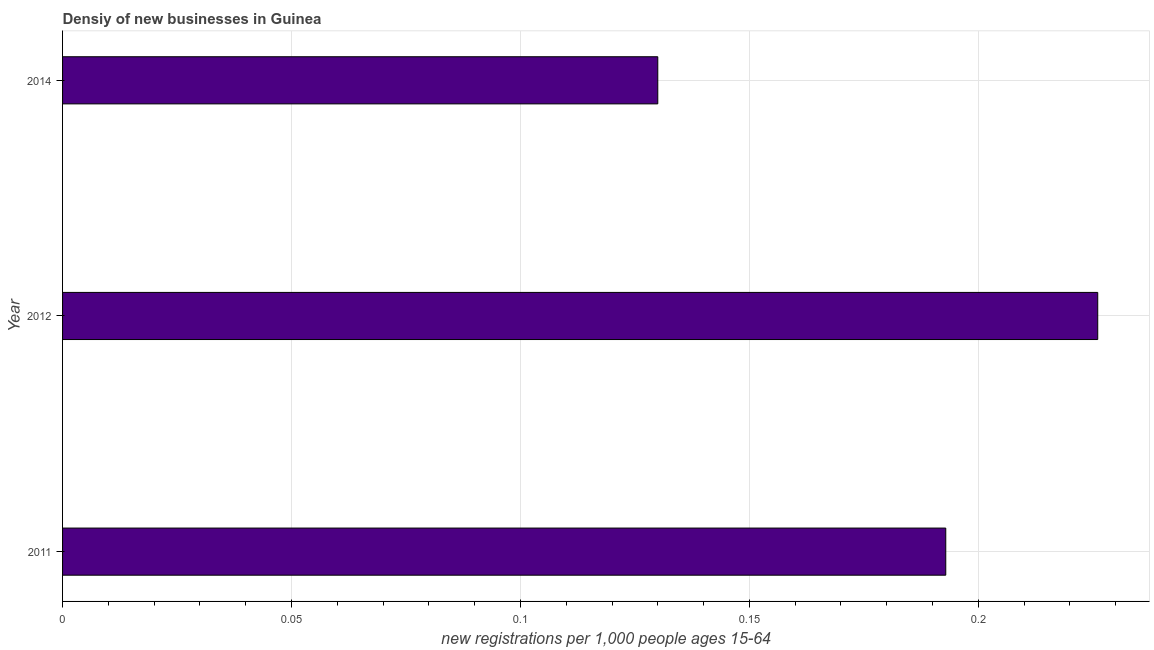Does the graph contain any zero values?
Ensure brevity in your answer.  No. Does the graph contain grids?
Your response must be concise. Yes. What is the title of the graph?
Offer a terse response. Densiy of new businesses in Guinea. What is the label or title of the X-axis?
Your answer should be compact. New registrations per 1,0 people ages 15-64. What is the label or title of the Y-axis?
Offer a very short reply. Year. What is the density of new business in 2011?
Offer a very short reply. 0.19. Across all years, what is the maximum density of new business?
Ensure brevity in your answer.  0.23. Across all years, what is the minimum density of new business?
Ensure brevity in your answer.  0.13. In which year was the density of new business maximum?
Provide a succinct answer. 2012. What is the sum of the density of new business?
Make the answer very short. 0.55. What is the difference between the density of new business in 2011 and 2014?
Make the answer very short. 0.06. What is the average density of new business per year?
Provide a succinct answer. 0.18. What is the median density of new business?
Keep it short and to the point. 0.19. Do a majority of the years between 2014 and 2011 (inclusive) have density of new business greater than 0.14 ?
Offer a very short reply. Yes. What is the ratio of the density of new business in 2011 to that in 2014?
Ensure brevity in your answer.  1.48. Is the density of new business in 2012 less than that in 2014?
Make the answer very short. No. Is the difference between the density of new business in 2011 and 2014 greater than the difference between any two years?
Your answer should be very brief. No. What is the difference between the highest and the second highest density of new business?
Keep it short and to the point. 0.03. What is the difference between the highest and the lowest density of new business?
Give a very brief answer. 0.1. In how many years, is the density of new business greater than the average density of new business taken over all years?
Give a very brief answer. 2. How many bars are there?
Your response must be concise. 3. Are the values on the major ticks of X-axis written in scientific E-notation?
Offer a terse response. No. What is the new registrations per 1,000 people ages 15-64 of 2011?
Keep it short and to the point. 0.19. What is the new registrations per 1,000 people ages 15-64 in 2012?
Provide a succinct answer. 0.23. What is the new registrations per 1,000 people ages 15-64 in 2014?
Provide a succinct answer. 0.13. What is the difference between the new registrations per 1,000 people ages 15-64 in 2011 and 2012?
Offer a terse response. -0.03. What is the difference between the new registrations per 1,000 people ages 15-64 in 2011 and 2014?
Offer a terse response. 0.06. What is the difference between the new registrations per 1,000 people ages 15-64 in 2012 and 2014?
Keep it short and to the point. 0.1. What is the ratio of the new registrations per 1,000 people ages 15-64 in 2011 to that in 2012?
Keep it short and to the point. 0.85. What is the ratio of the new registrations per 1,000 people ages 15-64 in 2011 to that in 2014?
Your response must be concise. 1.48. What is the ratio of the new registrations per 1,000 people ages 15-64 in 2012 to that in 2014?
Offer a very short reply. 1.74. 